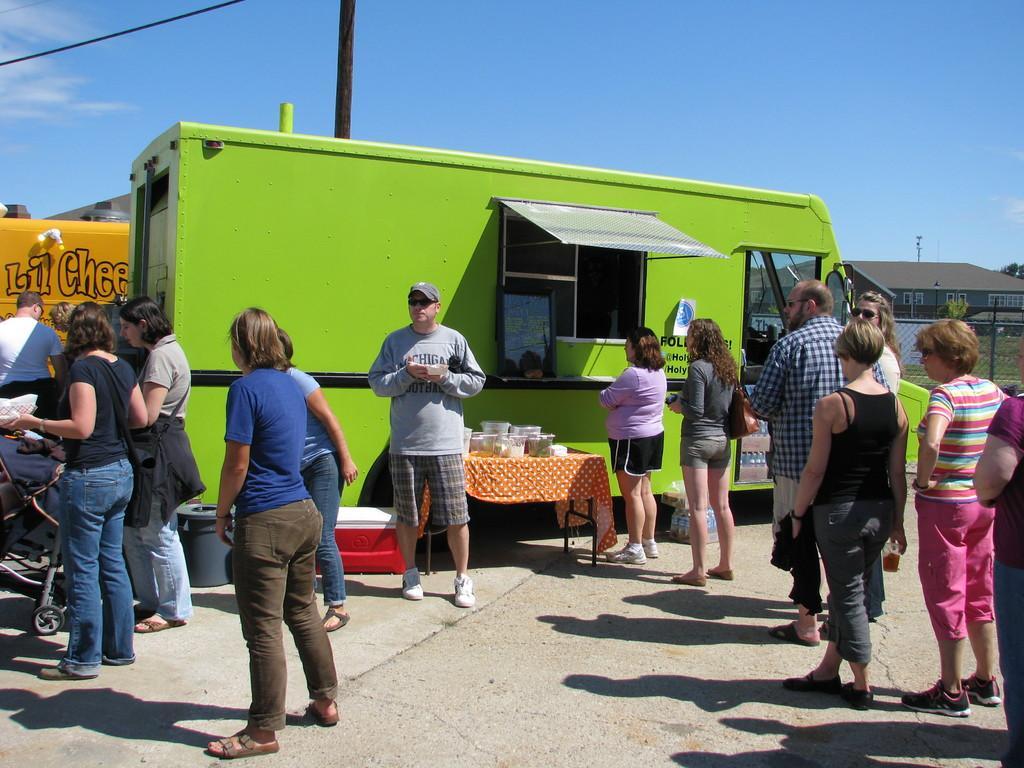How would you summarize this image in a sentence or two? In this image I can see people standing among them some are holding objects in their hands. Here I can see a green color food truck, a table on which has some objects. In the background I can see fence, buildings and the sky. 